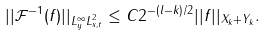<formula> <loc_0><loc_0><loc_500><loc_500>| | \mathcal { F } ^ { - 1 } ( f ) | | _ { L ^ { \infty } _ { y } L ^ { 2 } _ { x , t } } \leq C 2 ^ { - ( l - k ) / 2 } | | f | | _ { X _ { k } + Y _ { k } } .</formula> 